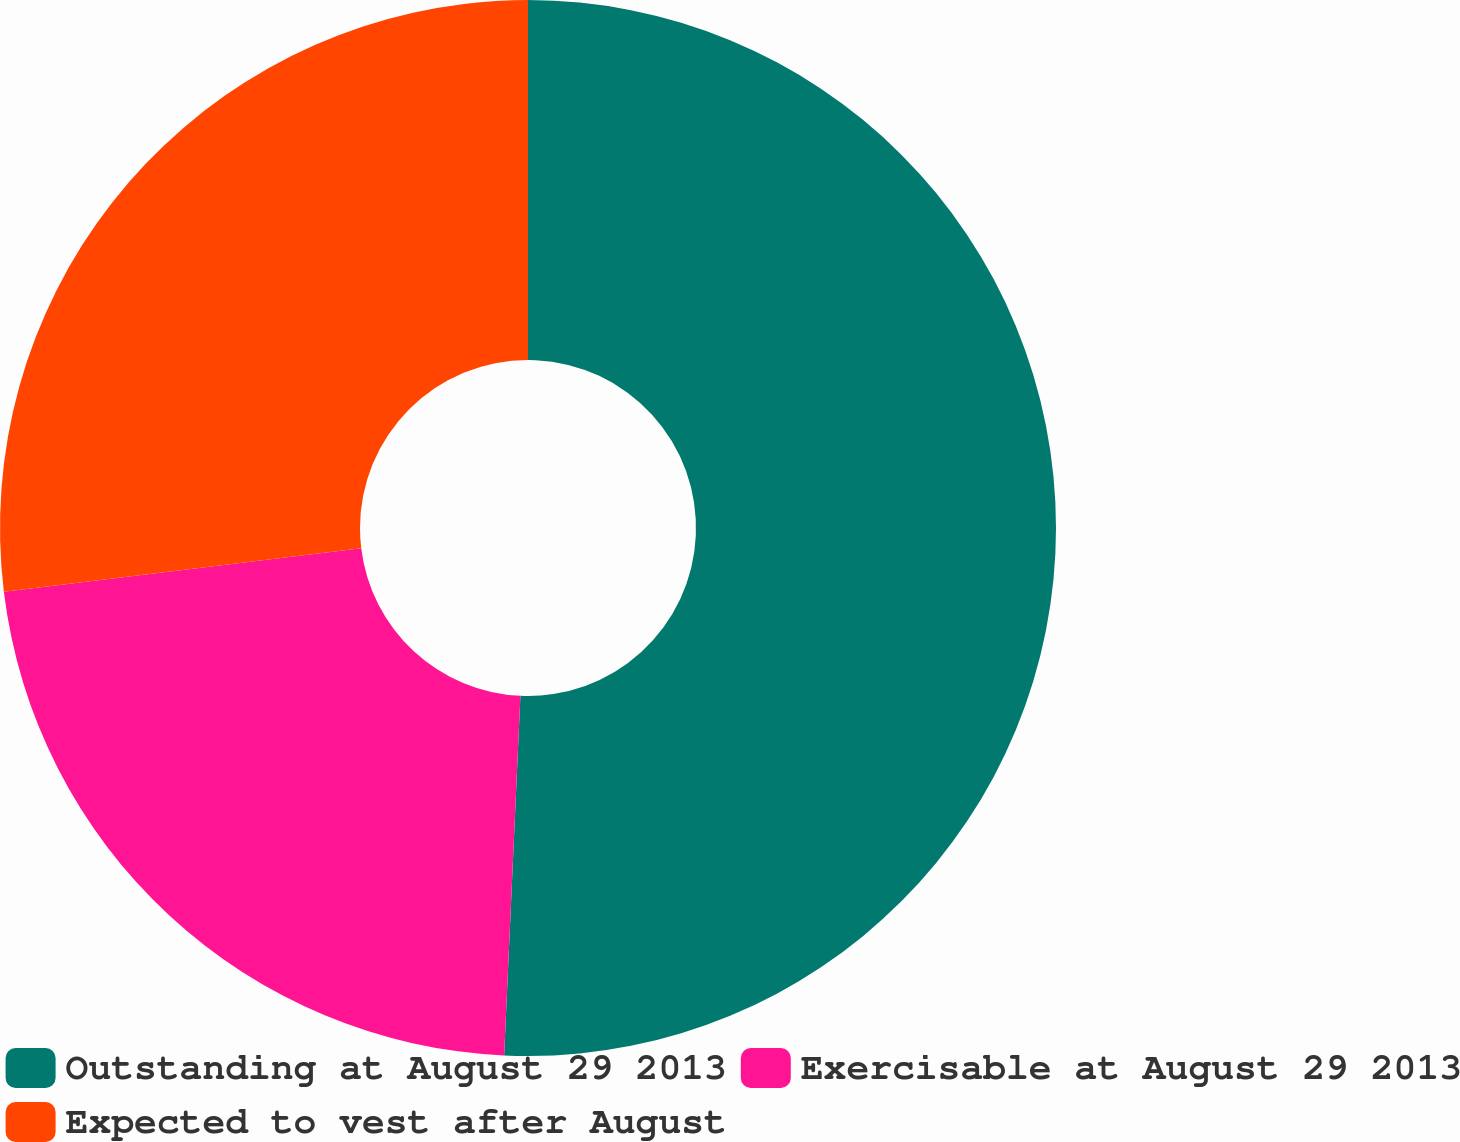<chart> <loc_0><loc_0><loc_500><loc_500><pie_chart><fcel>Outstanding at August 29 2013<fcel>Exercisable at August 29 2013<fcel>Expected to vest after August<nl><fcel>50.72%<fcel>22.35%<fcel>26.93%<nl></chart> 